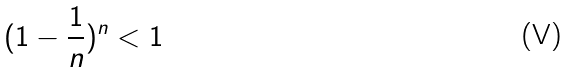<formula> <loc_0><loc_0><loc_500><loc_500>( 1 - \frac { 1 } { n } ) ^ { n } < 1</formula> 